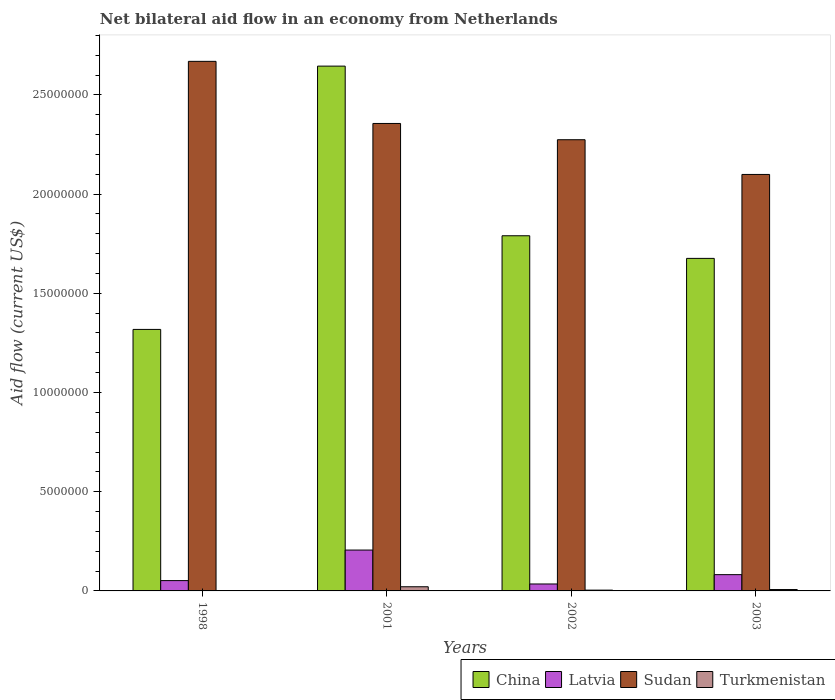How many different coloured bars are there?
Ensure brevity in your answer.  4. Are the number of bars on each tick of the X-axis equal?
Your response must be concise. Yes. How many bars are there on the 1st tick from the right?
Provide a succinct answer. 4. What is the label of the 4th group of bars from the left?
Keep it short and to the point. 2003. In how many cases, is the number of bars for a given year not equal to the number of legend labels?
Offer a very short reply. 0. What is the net bilateral aid flow in China in 2001?
Give a very brief answer. 2.64e+07. Across all years, what is the maximum net bilateral aid flow in Sudan?
Offer a very short reply. 2.67e+07. In which year was the net bilateral aid flow in Sudan maximum?
Your answer should be very brief. 1998. What is the total net bilateral aid flow in Sudan in the graph?
Your answer should be compact. 9.40e+07. What is the difference between the net bilateral aid flow in China in 2002 and that in 2003?
Your answer should be compact. 1.14e+06. What is the difference between the net bilateral aid flow in Turkmenistan in 2001 and the net bilateral aid flow in Latvia in 2002?
Make the answer very short. -1.40e+05. What is the average net bilateral aid flow in Sudan per year?
Offer a terse response. 2.35e+07. In the year 2001, what is the difference between the net bilateral aid flow in Sudan and net bilateral aid flow in Latvia?
Provide a short and direct response. 2.15e+07. In how many years, is the net bilateral aid flow in China greater than 1000000 US$?
Give a very brief answer. 4. What is the ratio of the net bilateral aid flow in China in 2002 to that in 2003?
Keep it short and to the point. 1.07. What is the difference between the highest and the second highest net bilateral aid flow in Sudan?
Your answer should be compact. 3.13e+06. What is the difference between the highest and the lowest net bilateral aid flow in Latvia?
Provide a succinct answer. 1.71e+06. In how many years, is the net bilateral aid flow in Turkmenistan greater than the average net bilateral aid flow in Turkmenistan taken over all years?
Your response must be concise. 1. Is the sum of the net bilateral aid flow in Latvia in 2002 and 2003 greater than the maximum net bilateral aid flow in China across all years?
Offer a very short reply. No. Is it the case that in every year, the sum of the net bilateral aid flow in Latvia and net bilateral aid flow in Sudan is greater than the sum of net bilateral aid flow in China and net bilateral aid flow in Turkmenistan?
Give a very brief answer. Yes. What does the 4th bar from the left in 2003 represents?
Offer a terse response. Turkmenistan. What does the 2nd bar from the right in 2003 represents?
Provide a short and direct response. Sudan. How many bars are there?
Provide a short and direct response. 16. How many years are there in the graph?
Provide a short and direct response. 4. Does the graph contain grids?
Ensure brevity in your answer.  No. Where does the legend appear in the graph?
Keep it short and to the point. Bottom right. How many legend labels are there?
Keep it short and to the point. 4. How are the legend labels stacked?
Provide a short and direct response. Horizontal. What is the title of the graph?
Keep it short and to the point. Net bilateral aid flow in an economy from Netherlands. What is the Aid flow (current US$) of China in 1998?
Make the answer very short. 1.32e+07. What is the Aid flow (current US$) of Latvia in 1998?
Provide a succinct answer. 5.20e+05. What is the Aid flow (current US$) in Sudan in 1998?
Give a very brief answer. 2.67e+07. What is the Aid flow (current US$) in Turkmenistan in 1998?
Your response must be concise. 10000. What is the Aid flow (current US$) of China in 2001?
Offer a very short reply. 2.64e+07. What is the Aid flow (current US$) in Latvia in 2001?
Make the answer very short. 2.06e+06. What is the Aid flow (current US$) of Sudan in 2001?
Provide a succinct answer. 2.36e+07. What is the Aid flow (current US$) in Turkmenistan in 2001?
Your answer should be very brief. 2.10e+05. What is the Aid flow (current US$) in China in 2002?
Give a very brief answer. 1.79e+07. What is the Aid flow (current US$) in Latvia in 2002?
Provide a short and direct response. 3.50e+05. What is the Aid flow (current US$) of Sudan in 2002?
Your answer should be very brief. 2.27e+07. What is the Aid flow (current US$) of Turkmenistan in 2002?
Give a very brief answer. 4.00e+04. What is the Aid flow (current US$) in China in 2003?
Offer a terse response. 1.68e+07. What is the Aid flow (current US$) in Latvia in 2003?
Ensure brevity in your answer.  8.20e+05. What is the Aid flow (current US$) in Sudan in 2003?
Keep it short and to the point. 2.10e+07. Across all years, what is the maximum Aid flow (current US$) in China?
Provide a short and direct response. 2.64e+07. Across all years, what is the maximum Aid flow (current US$) of Latvia?
Your answer should be very brief. 2.06e+06. Across all years, what is the maximum Aid flow (current US$) of Sudan?
Offer a very short reply. 2.67e+07. Across all years, what is the minimum Aid flow (current US$) in China?
Keep it short and to the point. 1.32e+07. Across all years, what is the minimum Aid flow (current US$) in Latvia?
Provide a short and direct response. 3.50e+05. Across all years, what is the minimum Aid flow (current US$) in Sudan?
Your answer should be very brief. 2.10e+07. Across all years, what is the minimum Aid flow (current US$) in Turkmenistan?
Provide a short and direct response. 10000. What is the total Aid flow (current US$) of China in the graph?
Your answer should be compact. 7.43e+07. What is the total Aid flow (current US$) in Latvia in the graph?
Your response must be concise. 3.75e+06. What is the total Aid flow (current US$) in Sudan in the graph?
Keep it short and to the point. 9.40e+07. What is the difference between the Aid flow (current US$) in China in 1998 and that in 2001?
Provide a succinct answer. -1.33e+07. What is the difference between the Aid flow (current US$) of Latvia in 1998 and that in 2001?
Give a very brief answer. -1.54e+06. What is the difference between the Aid flow (current US$) in Sudan in 1998 and that in 2001?
Your answer should be very brief. 3.13e+06. What is the difference between the Aid flow (current US$) in Turkmenistan in 1998 and that in 2001?
Keep it short and to the point. -2.00e+05. What is the difference between the Aid flow (current US$) of China in 1998 and that in 2002?
Ensure brevity in your answer.  -4.72e+06. What is the difference between the Aid flow (current US$) of Latvia in 1998 and that in 2002?
Make the answer very short. 1.70e+05. What is the difference between the Aid flow (current US$) of Sudan in 1998 and that in 2002?
Ensure brevity in your answer.  3.95e+06. What is the difference between the Aid flow (current US$) of China in 1998 and that in 2003?
Offer a terse response. -3.58e+06. What is the difference between the Aid flow (current US$) in Latvia in 1998 and that in 2003?
Provide a short and direct response. -3.00e+05. What is the difference between the Aid flow (current US$) of Sudan in 1998 and that in 2003?
Provide a short and direct response. 5.70e+06. What is the difference between the Aid flow (current US$) in China in 2001 and that in 2002?
Offer a terse response. 8.55e+06. What is the difference between the Aid flow (current US$) of Latvia in 2001 and that in 2002?
Make the answer very short. 1.71e+06. What is the difference between the Aid flow (current US$) in Sudan in 2001 and that in 2002?
Make the answer very short. 8.20e+05. What is the difference between the Aid flow (current US$) of China in 2001 and that in 2003?
Provide a succinct answer. 9.69e+06. What is the difference between the Aid flow (current US$) in Latvia in 2001 and that in 2003?
Ensure brevity in your answer.  1.24e+06. What is the difference between the Aid flow (current US$) of Sudan in 2001 and that in 2003?
Keep it short and to the point. 2.57e+06. What is the difference between the Aid flow (current US$) of Turkmenistan in 2001 and that in 2003?
Your response must be concise. 1.40e+05. What is the difference between the Aid flow (current US$) in China in 2002 and that in 2003?
Make the answer very short. 1.14e+06. What is the difference between the Aid flow (current US$) in Latvia in 2002 and that in 2003?
Provide a short and direct response. -4.70e+05. What is the difference between the Aid flow (current US$) in Sudan in 2002 and that in 2003?
Offer a terse response. 1.75e+06. What is the difference between the Aid flow (current US$) in Turkmenistan in 2002 and that in 2003?
Provide a short and direct response. -3.00e+04. What is the difference between the Aid flow (current US$) of China in 1998 and the Aid flow (current US$) of Latvia in 2001?
Make the answer very short. 1.11e+07. What is the difference between the Aid flow (current US$) of China in 1998 and the Aid flow (current US$) of Sudan in 2001?
Ensure brevity in your answer.  -1.04e+07. What is the difference between the Aid flow (current US$) in China in 1998 and the Aid flow (current US$) in Turkmenistan in 2001?
Your answer should be compact. 1.30e+07. What is the difference between the Aid flow (current US$) of Latvia in 1998 and the Aid flow (current US$) of Sudan in 2001?
Your answer should be compact. -2.30e+07. What is the difference between the Aid flow (current US$) in Latvia in 1998 and the Aid flow (current US$) in Turkmenistan in 2001?
Offer a very short reply. 3.10e+05. What is the difference between the Aid flow (current US$) in Sudan in 1998 and the Aid flow (current US$) in Turkmenistan in 2001?
Offer a very short reply. 2.65e+07. What is the difference between the Aid flow (current US$) of China in 1998 and the Aid flow (current US$) of Latvia in 2002?
Your response must be concise. 1.28e+07. What is the difference between the Aid flow (current US$) of China in 1998 and the Aid flow (current US$) of Sudan in 2002?
Your answer should be compact. -9.56e+06. What is the difference between the Aid flow (current US$) of China in 1998 and the Aid flow (current US$) of Turkmenistan in 2002?
Make the answer very short. 1.31e+07. What is the difference between the Aid flow (current US$) of Latvia in 1998 and the Aid flow (current US$) of Sudan in 2002?
Your answer should be compact. -2.22e+07. What is the difference between the Aid flow (current US$) of Sudan in 1998 and the Aid flow (current US$) of Turkmenistan in 2002?
Your answer should be compact. 2.66e+07. What is the difference between the Aid flow (current US$) in China in 1998 and the Aid flow (current US$) in Latvia in 2003?
Offer a very short reply. 1.24e+07. What is the difference between the Aid flow (current US$) in China in 1998 and the Aid flow (current US$) in Sudan in 2003?
Make the answer very short. -7.81e+06. What is the difference between the Aid flow (current US$) in China in 1998 and the Aid flow (current US$) in Turkmenistan in 2003?
Provide a succinct answer. 1.31e+07. What is the difference between the Aid flow (current US$) of Latvia in 1998 and the Aid flow (current US$) of Sudan in 2003?
Your response must be concise. -2.05e+07. What is the difference between the Aid flow (current US$) of Sudan in 1998 and the Aid flow (current US$) of Turkmenistan in 2003?
Offer a very short reply. 2.66e+07. What is the difference between the Aid flow (current US$) of China in 2001 and the Aid flow (current US$) of Latvia in 2002?
Provide a short and direct response. 2.61e+07. What is the difference between the Aid flow (current US$) in China in 2001 and the Aid flow (current US$) in Sudan in 2002?
Your answer should be very brief. 3.71e+06. What is the difference between the Aid flow (current US$) in China in 2001 and the Aid flow (current US$) in Turkmenistan in 2002?
Offer a very short reply. 2.64e+07. What is the difference between the Aid flow (current US$) in Latvia in 2001 and the Aid flow (current US$) in Sudan in 2002?
Give a very brief answer. -2.07e+07. What is the difference between the Aid flow (current US$) in Latvia in 2001 and the Aid flow (current US$) in Turkmenistan in 2002?
Make the answer very short. 2.02e+06. What is the difference between the Aid flow (current US$) of Sudan in 2001 and the Aid flow (current US$) of Turkmenistan in 2002?
Your answer should be compact. 2.35e+07. What is the difference between the Aid flow (current US$) in China in 2001 and the Aid flow (current US$) in Latvia in 2003?
Provide a succinct answer. 2.56e+07. What is the difference between the Aid flow (current US$) of China in 2001 and the Aid flow (current US$) of Sudan in 2003?
Your response must be concise. 5.46e+06. What is the difference between the Aid flow (current US$) in China in 2001 and the Aid flow (current US$) in Turkmenistan in 2003?
Offer a very short reply. 2.64e+07. What is the difference between the Aid flow (current US$) of Latvia in 2001 and the Aid flow (current US$) of Sudan in 2003?
Give a very brief answer. -1.89e+07. What is the difference between the Aid flow (current US$) in Latvia in 2001 and the Aid flow (current US$) in Turkmenistan in 2003?
Keep it short and to the point. 1.99e+06. What is the difference between the Aid flow (current US$) of Sudan in 2001 and the Aid flow (current US$) of Turkmenistan in 2003?
Ensure brevity in your answer.  2.35e+07. What is the difference between the Aid flow (current US$) of China in 2002 and the Aid flow (current US$) of Latvia in 2003?
Provide a short and direct response. 1.71e+07. What is the difference between the Aid flow (current US$) in China in 2002 and the Aid flow (current US$) in Sudan in 2003?
Offer a terse response. -3.09e+06. What is the difference between the Aid flow (current US$) of China in 2002 and the Aid flow (current US$) of Turkmenistan in 2003?
Your answer should be compact. 1.78e+07. What is the difference between the Aid flow (current US$) in Latvia in 2002 and the Aid flow (current US$) in Sudan in 2003?
Give a very brief answer. -2.06e+07. What is the difference between the Aid flow (current US$) in Sudan in 2002 and the Aid flow (current US$) in Turkmenistan in 2003?
Make the answer very short. 2.27e+07. What is the average Aid flow (current US$) of China per year?
Ensure brevity in your answer.  1.86e+07. What is the average Aid flow (current US$) in Latvia per year?
Provide a succinct answer. 9.38e+05. What is the average Aid flow (current US$) in Sudan per year?
Your response must be concise. 2.35e+07. What is the average Aid flow (current US$) of Turkmenistan per year?
Provide a short and direct response. 8.25e+04. In the year 1998, what is the difference between the Aid flow (current US$) in China and Aid flow (current US$) in Latvia?
Make the answer very short. 1.27e+07. In the year 1998, what is the difference between the Aid flow (current US$) of China and Aid flow (current US$) of Sudan?
Offer a terse response. -1.35e+07. In the year 1998, what is the difference between the Aid flow (current US$) in China and Aid flow (current US$) in Turkmenistan?
Your answer should be very brief. 1.32e+07. In the year 1998, what is the difference between the Aid flow (current US$) of Latvia and Aid flow (current US$) of Sudan?
Provide a short and direct response. -2.62e+07. In the year 1998, what is the difference between the Aid flow (current US$) of Latvia and Aid flow (current US$) of Turkmenistan?
Offer a terse response. 5.10e+05. In the year 1998, what is the difference between the Aid flow (current US$) in Sudan and Aid flow (current US$) in Turkmenistan?
Offer a very short reply. 2.67e+07. In the year 2001, what is the difference between the Aid flow (current US$) in China and Aid flow (current US$) in Latvia?
Offer a very short reply. 2.44e+07. In the year 2001, what is the difference between the Aid flow (current US$) of China and Aid flow (current US$) of Sudan?
Provide a succinct answer. 2.89e+06. In the year 2001, what is the difference between the Aid flow (current US$) in China and Aid flow (current US$) in Turkmenistan?
Provide a short and direct response. 2.62e+07. In the year 2001, what is the difference between the Aid flow (current US$) of Latvia and Aid flow (current US$) of Sudan?
Your response must be concise. -2.15e+07. In the year 2001, what is the difference between the Aid flow (current US$) in Latvia and Aid flow (current US$) in Turkmenistan?
Provide a succinct answer. 1.85e+06. In the year 2001, what is the difference between the Aid flow (current US$) in Sudan and Aid flow (current US$) in Turkmenistan?
Keep it short and to the point. 2.34e+07. In the year 2002, what is the difference between the Aid flow (current US$) in China and Aid flow (current US$) in Latvia?
Give a very brief answer. 1.76e+07. In the year 2002, what is the difference between the Aid flow (current US$) in China and Aid flow (current US$) in Sudan?
Offer a very short reply. -4.84e+06. In the year 2002, what is the difference between the Aid flow (current US$) in China and Aid flow (current US$) in Turkmenistan?
Offer a terse response. 1.79e+07. In the year 2002, what is the difference between the Aid flow (current US$) in Latvia and Aid flow (current US$) in Sudan?
Keep it short and to the point. -2.24e+07. In the year 2002, what is the difference between the Aid flow (current US$) in Sudan and Aid flow (current US$) in Turkmenistan?
Your answer should be compact. 2.27e+07. In the year 2003, what is the difference between the Aid flow (current US$) of China and Aid flow (current US$) of Latvia?
Give a very brief answer. 1.59e+07. In the year 2003, what is the difference between the Aid flow (current US$) of China and Aid flow (current US$) of Sudan?
Ensure brevity in your answer.  -4.23e+06. In the year 2003, what is the difference between the Aid flow (current US$) of China and Aid flow (current US$) of Turkmenistan?
Your answer should be compact. 1.67e+07. In the year 2003, what is the difference between the Aid flow (current US$) in Latvia and Aid flow (current US$) in Sudan?
Provide a succinct answer. -2.02e+07. In the year 2003, what is the difference between the Aid flow (current US$) of Latvia and Aid flow (current US$) of Turkmenistan?
Your response must be concise. 7.50e+05. In the year 2003, what is the difference between the Aid flow (current US$) in Sudan and Aid flow (current US$) in Turkmenistan?
Give a very brief answer. 2.09e+07. What is the ratio of the Aid flow (current US$) in China in 1998 to that in 2001?
Ensure brevity in your answer.  0.5. What is the ratio of the Aid flow (current US$) in Latvia in 1998 to that in 2001?
Make the answer very short. 0.25. What is the ratio of the Aid flow (current US$) of Sudan in 1998 to that in 2001?
Offer a very short reply. 1.13. What is the ratio of the Aid flow (current US$) in Turkmenistan in 1998 to that in 2001?
Keep it short and to the point. 0.05. What is the ratio of the Aid flow (current US$) in China in 1998 to that in 2002?
Your answer should be compact. 0.74. What is the ratio of the Aid flow (current US$) of Latvia in 1998 to that in 2002?
Offer a very short reply. 1.49. What is the ratio of the Aid flow (current US$) of Sudan in 1998 to that in 2002?
Make the answer very short. 1.17. What is the ratio of the Aid flow (current US$) of China in 1998 to that in 2003?
Your response must be concise. 0.79. What is the ratio of the Aid flow (current US$) of Latvia in 1998 to that in 2003?
Your answer should be very brief. 0.63. What is the ratio of the Aid flow (current US$) of Sudan in 1998 to that in 2003?
Provide a short and direct response. 1.27. What is the ratio of the Aid flow (current US$) of Turkmenistan in 1998 to that in 2003?
Provide a succinct answer. 0.14. What is the ratio of the Aid flow (current US$) of China in 2001 to that in 2002?
Make the answer very short. 1.48. What is the ratio of the Aid flow (current US$) of Latvia in 2001 to that in 2002?
Keep it short and to the point. 5.89. What is the ratio of the Aid flow (current US$) in Sudan in 2001 to that in 2002?
Your answer should be very brief. 1.04. What is the ratio of the Aid flow (current US$) in Turkmenistan in 2001 to that in 2002?
Your answer should be very brief. 5.25. What is the ratio of the Aid flow (current US$) of China in 2001 to that in 2003?
Provide a short and direct response. 1.58. What is the ratio of the Aid flow (current US$) in Latvia in 2001 to that in 2003?
Your response must be concise. 2.51. What is the ratio of the Aid flow (current US$) of Sudan in 2001 to that in 2003?
Offer a terse response. 1.12. What is the ratio of the Aid flow (current US$) of China in 2002 to that in 2003?
Ensure brevity in your answer.  1.07. What is the ratio of the Aid flow (current US$) in Latvia in 2002 to that in 2003?
Make the answer very short. 0.43. What is the ratio of the Aid flow (current US$) in Sudan in 2002 to that in 2003?
Give a very brief answer. 1.08. What is the ratio of the Aid flow (current US$) in Turkmenistan in 2002 to that in 2003?
Provide a succinct answer. 0.57. What is the difference between the highest and the second highest Aid flow (current US$) in China?
Give a very brief answer. 8.55e+06. What is the difference between the highest and the second highest Aid flow (current US$) in Latvia?
Give a very brief answer. 1.24e+06. What is the difference between the highest and the second highest Aid flow (current US$) of Sudan?
Offer a very short reply. 3.13e+06. What is the difference between the highest and the lowest Aid flow (current US$) in China?
Provide a short and direct response. 1.33e+07. What is the difference between the highest and the lowest Aid flow (current US$) of Latvia?
Ensure brevity in your answer.  1.71e+06. What is the difference between the highest and the lowest Aid flow (current US$) in Sudan?
Offer a terse response. 5.70e+06. 